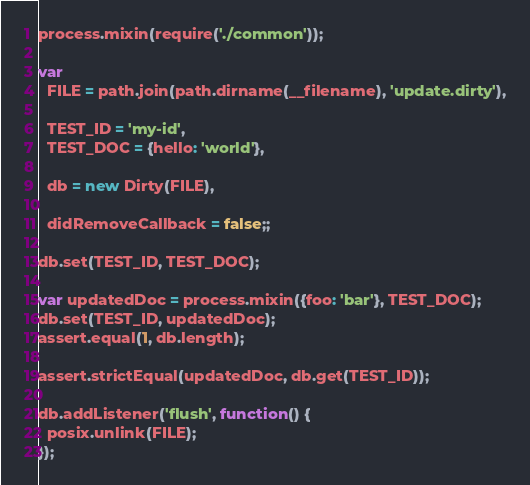Convert code to text. <code><loc_0><loc_0><loc_500><loc_500><_JavaScript_>process.mixin(require('./common'));

var
  FILE = path.join(path.dirname(__filename), 'update.dirty'),

  TEST_ID = 'my-id',
  TEST_DOC = {hello: 'world'},

  db = new Dirty(FILE),

  didRemoveCallback = false;;
  
db.set(TEST_ID, TEST_DOC);

var updatedDoc = process.mixin({foo: 'bar'}, TEST_DOC);
db.set(TEST_ID, updatedDoc);
assert.equal(1, db.length);

assert.strictEqual(updatedDoc, db.get(TEST_ID));

db.addListener('flush', function() {
  posix.unlink(FILE);
});</code> 